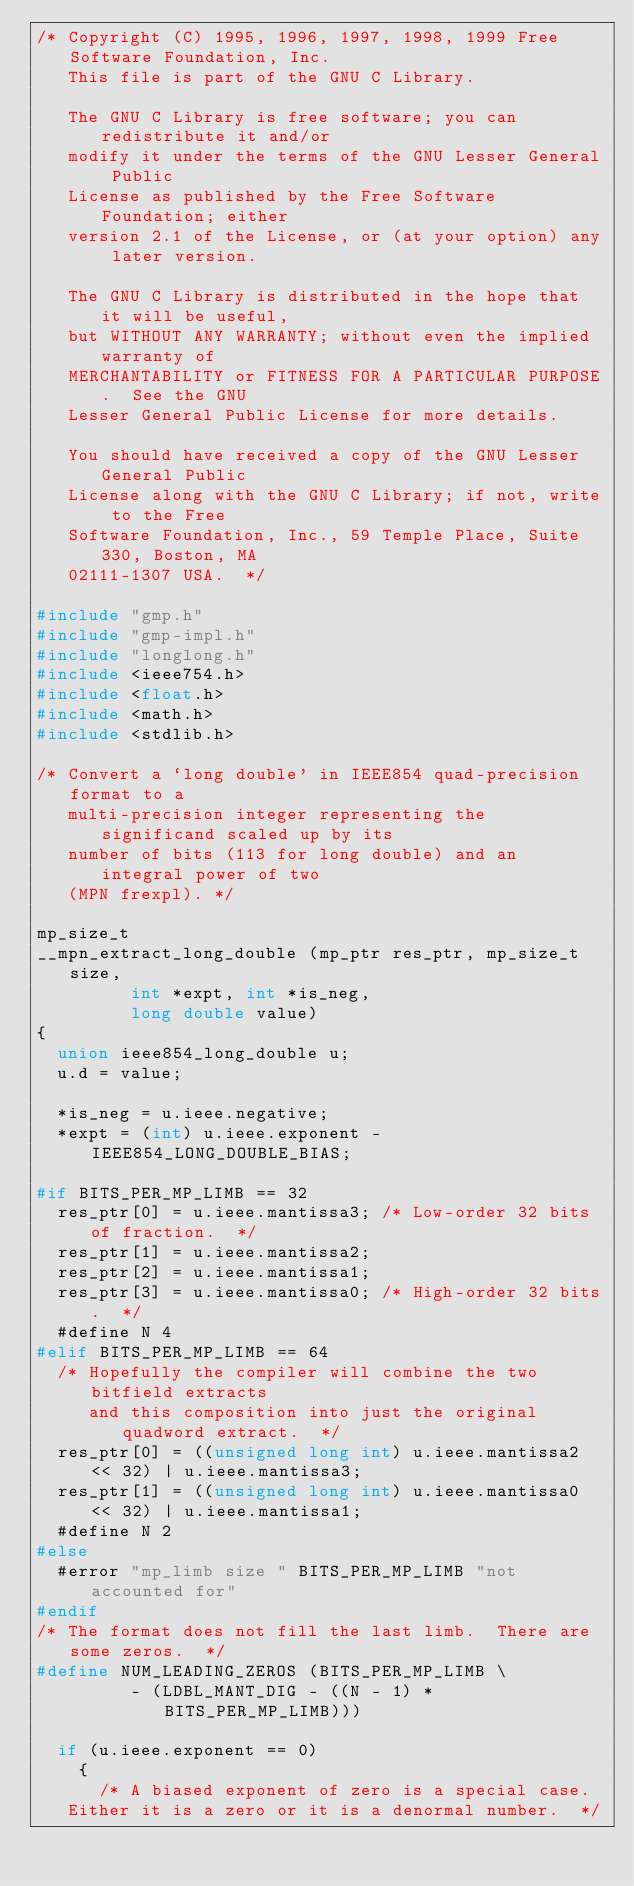Convert code to text. <code><loc_0><loc_0><loc_500><loc_500><_C_>/* Copyright (C) 1995, 1996, 1997, 1998, 1999 Free Software Foundation, Inc.
   This file is part of the GNU C Library.

   The GNU C Library is free software; you can redistribute it and/or
   modify it under the terms of the GNU Lesser General Public
   License as published by the Free Software Foundation; either
   version 2.1 of the License, or (at your option) any later version.

   The GNU C Library is distributed in the hope that it will be useful,
   but WITHOUT ANY WARRANTY; without even the implied warranty of
   MERCHANTABILITY or FITNESS FOR A PARTICULAR PURPOSE.  See the GNU
   Lesser General Public License for more details.

   You should have received a copy of the GNU Lesser General Public
   License along with the GNU C Library; if not, write to the Free
   Software Foundation, Inc., 59 Temple Place, Suite 330, Boston, MA
   02111-1307 USA.  */

#include "gmp.h"
#include "gmp-impl.h"
#include "longlong.h"
#include <ieee754.h>
#include <float.h>
#include <math.h>
#include <stdlib.h>

/* Convert a `long double' in IEEE854 quad-precision format to a
   multi-precision integer representing the significand scaled up by its
   number of bits (113 for long double) and an integral power of two
   (MPN frexpl). */

mp_size_t
__mpn_extract_long_double (mp_ptr res_ptr, mp_size_t size,
			   int *expt, int *is_neg,
			   long double value)
{
  union ieee854_long_double u;
  u.d = value;

  *is_neg = u.ieee.negative;
  *expt = (int) u.ieee.exponent - IEEE854_LONG_DOUBLE_BIAS;

#if BITS_PER_MP_LIMB == 32
  res_ptr[0] = u.ieee.mantissa3; /* Low-order 32 bits of fraction.  */
  res_ptr[1] = u.ieee.mantissa2;
  res_ptr[2] = u.ieee.mantissa1;
  res_ptr[3] = u.ieee.mantissa0; /* High-order 32 bits.  */
  #define N 4
#elif BITS_PER_MP_LIMB == 64
  /* Hopefully the compiler will combine the two bitfield extracts
     and this composition into just the original quadword extract.  */
  res_ptr[0] = ((unsigned long int) u.ieee.mantissa2 << 32) | u.ieee.mantissa3;
  res_ptr[1] = ((unsigned long int) u.ieee.mantissa0 << 32) | u.ieee.mantissa1;
  #define N 2
#else
  #error "mp_limb size " BITS_PER_MP_LIMB "not accounted for"
#endif
/* The format does not fill the last limb.  There are some zeros.  */
#define NUM_LEADING_ZEROS (BITS_PER_MP_LIMB \
			   - (LDBL_MANT_DIG - ((N - 1) * BITS_PER_MP_LIMB)))

  if (u.ieee.exponent == 0)
    {
      /* A biased exponent of zero is a special case.
	 Either it is a zero or it is a denormal number.  */</code> 